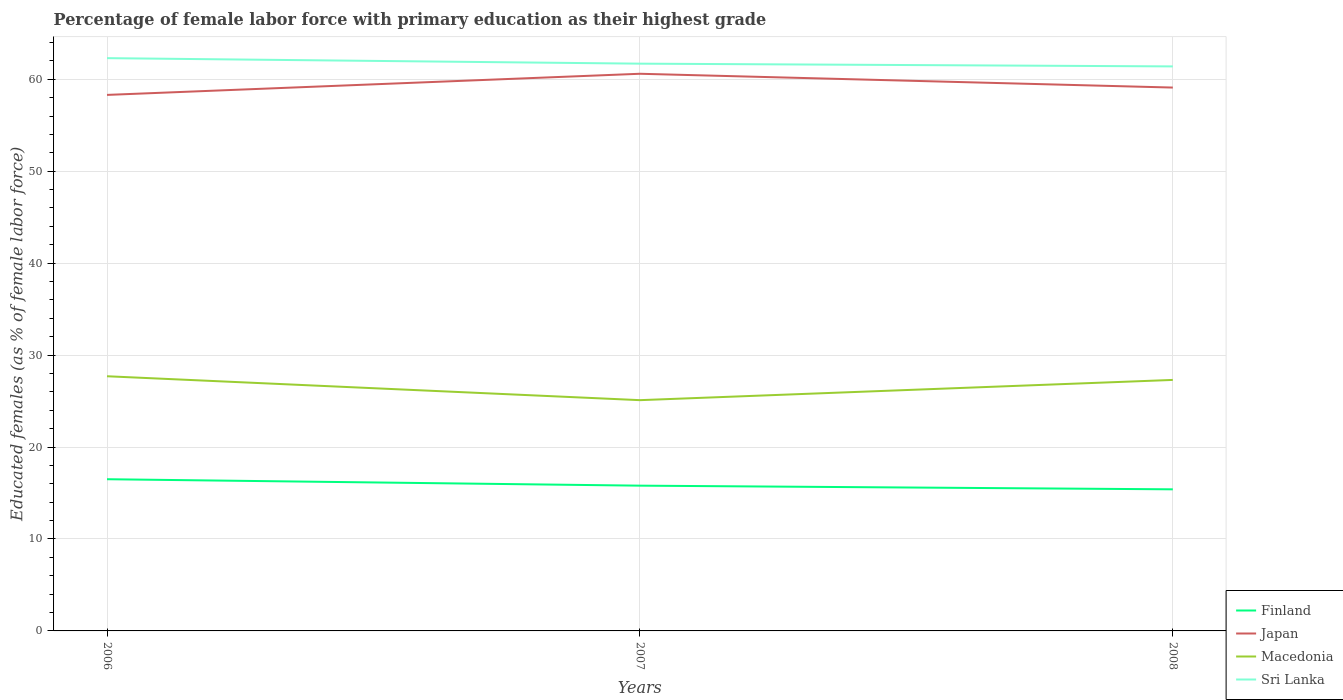Does the line corresponding to Macedonia intersect with the line corresponding to Sri Lanka?
Give a very brief answer. No. Is the number of lines equal to the number of legend labels?
Ensure brevity in your answer.  Yes. Across all years, what is the maximum percentage of female labor force with primary education in Sri Lanka?
Offer a very short reply. 61.4. In which year was the percentage of female labor force with primary education in Macedonia maximum?
Your response must be concise. 2007. What is the total percentage of female labor force with primary education in Finland in the graph?
Offer a very short reply. 1.1. What is the difference between the highest and the second highest percentage of female labor force with primary education in Finland?
Your answer should be very brief. 1.1. What is the difference between the highest and the lowest percentage of female labor force with primary education in Macedonia?
Offer a terse response. 2. How many lines are there?
Offer a terse response. 4. How many years are there in the graph?
Give a very brief answer. 3. Does the graph contain any zero values?
Your answer should be very brief. No. Does the graph contain grids?
Keep it short and to the point. Yes. How many legend labels are there?
Your response must be concise. 4. How are the legend labels stacked?
Ensure brevity in your answer.  Vertical. What is the title of the graph?
Offer a very short reply. Percentage of female labor force with primary education as their highest grade. Does "Peru" appear as one of the legend labels in the graph?
Your response must be concise. No. What is the label or title of the X-axis?
Provide a short and direct response. Years. What is the label or title of the Y-axis?
Offer a very short reply. Educated females (as % of female labor force). What is the Educated females (as % of female labor force) of Japan in 2006?
Your answer should be compact. 58.3. What is the Educated females (as % of female labor force) of Macedonia in 2006?
Offer a very short reply. 27.7. What is the Educated females (as % of female labor force) of Sri Lanka in 2006?
Make the answer very short. 62.3. What is the Educated females (as % of female labor force) of Finland in 2007?
Your answer should be compact. 15.8. What is the Educated females (as % of female labor force) in Japan in 2007?
Provide a short and direct response. 60.6. What is the Educated females (as % of female labor force) in Macedonia in 2007?
Provide a succinct answer. 25.1. What is the Educated females (as % of female labor force) of Sri Lanka in 2007?
Offer a very short reply. 61.7. What is the Educated females (as % of female labor force) of Finland in 2008?
Offer a terse response. 15.4. What is the Educated females (as % of female labor force) of Japan in 2008?
Ensure brevity in your answer.  59.1. What is the Educated females (as % of female labor force) of Macedonia in 2008?
Keep it short and to the point. 27.3. What is the Educated females (as % of female labor force) in Sri Lanka in 2008?
Offer a terse response. 61.4. Across all years, what is the maximum Educated females (as % of female labor force) of Japan?
Ensure brevity in your answer.  60.6. Across all years, what is the maximum Educated females (as % of female labor force) of Macedonia?
Provide a succinct answer. 27.7. Across all years, what is the maximum Educated females (as % of female labor force) of Sri Lanka?
Keep it short and to the point. 62.3. Across all years, what is the minimum Educated females (as % of female labor force) of Finland?
Give a very brief answer. 15.4. Across all years, what is the minimum Educated females (as % of female labor force) in Japan?
Provide a short and direct response. 58.3. Across all years, what is the minimum Educated females (as % of female labor force) in Macedonia?
Your answer should be compact. 25.1. Across all years, what is the minimum Educated females (as % of female labor force) in Sri Lanka?
Make the answer very short. 61.4. What is the total Educated females (as % of female labor force) in Finland in the graph?
Provide a succinct answer. 47.7. What is the total Educated females (as % of female labor force) in Japan in the graph?
Keep it short and to the point. 178. What is the total Educated females (as % of female labor force) in Macedonia in the graph?
Ensure brevity in your answer.  80.1. What is the total Educated females (as % of female labor force) in Sri Lanka in the graph?
Give a very brief answer. 185.4. What is the difference between the Educated females (as % of female labor force) in Macedonia in 2006 and that in 2007?
Offer a very short reply. 2.6. What is the difference between the Educated females (as % of female labor force) of Sri Lanka in 2006 and that in 2007?
Keep it short and to the point. 0.6. What is the difference between the Educated females (as % of female labor force) in Japan in 2006 and that in 2008?
Your answer should be compact. -0.8. What is the difference between the Educated females (as % of female labor force) in Macedonia in 2006 and that in 2008?
Keep it short and to the point. 0.4. What is the difference between the Educated females (as % of female labor force) in Sri Lanka in 2006 and that in 2008?
Keep it short and to the point. 0.9. What is the difference between the Educated females (as % of female labor force) of Macedonia in 2007 and that in 2008?
Your response must be concise. -2.2. What is the difference between the Educated females (as % of female labor force) of Sri Lanka in 2007 and that in 2008?
Make the answer very short. 0.3. What is the difference between the Educated females (as % of female labor force) in Finland in 2006 and the Educated females (as % of female labor force) in Japan in 2007?
Offer a terse response. -44.1. What is the difference between the Educated females (as % of female labor force) of Finland in 2006 and the Educated females (as % of female labor force) of Macedonia in 2007?
Ensure brevity in your answer.  -8.6. What is the difference between the Educated females (as % of female labor force) of Finland in 2006 and the Educated females (as % of female labor force) of Sri Lanka in 2007?
Keep it short and to the point. -45.2. What is the difference between the Educated females (as % of female labor force) of Japan in 2006 and the Educated females (as % of female labor force) of Macedonia in 2007?
Offer a very short reply. 33.2. What is the difference between the Educated females (as % of female labor force) in Japan in 2006 and the Educated females (as % of female labor force) in Sri Lanka in 2007?
Your response must be concise. -3.4. What is the difference between the Educated females (as % of female labor force) in Macedonia in 2006 and the Educated females (as % of female labor force) in Sri Lanka in 2007?
Offer a very short reply. -34. What is the difference between the Educated females (as % of female labor force) of Finland in 2006 and the Educated females (as % of female labor force) of Japan in 2008?
Offer a terse response. -42.6. What is the difference between the Educated females (as % of female labor force) in Finland in 2006 and the Educated females (as % of female labor force) in Macedonia in 2008?
Give a very brief answer. -10.8. What is the difference between the Educated females (as % of female labor force) of Finland in 2006 and the Educated females (as % of female labor force) of Sri Lanka in 2008?
Offer a very short reply. -44.9. What is the difference between the Educated females (as % of female labor force) in Japan in 2006 and the Educated females (as % of female labor force) in Macedonia in 2008?
Ensure brevity in your answer.  31. What is the difference between the Educated females (as % of female labor force) in Macedonia in 2006 and the Educated females (as % of female labor force) in Sri Lanka in 2008?
Give a very brief answer. -33.7. What is the difference between the Educated females (as % of female labor force) in Finland in 2007 and the Educated females (as % of female labor force) in Japan in 2008?
Offer a terse response. -43.3. What is the difference between the Educated females (as % of female labor force) in Finland in 2007 and the Educated females (as % of female labor force) in Sri Lanka in 2008?
Offer a terse response. -45.6. What is the difference between the Educated females (as % of female labor force) of Japan in 2007 and the Educated females (as % of female labor force) of Macedonia in 2008?
Offer a terse response. 33.3. What is the difference between the Educated females (as % of female labor force) in Japan in 2007 and the Educated females (as % of female labor force) in Sri Lanka in 2008?
Make the answer very short. -0.8. What is the difference between the Educated females (as % of female labor force) in Macedonia in 2007 and the Educated females (as % of female labor force) in Sri Lanka in 2008?
Your answer should be very brief. -36.3. What is the average Educated females (as % of female labor force) of Finland per year?
Provide a short and direct response. 15.9. What is the average Educated females (as % of female labor force) in Japan per year?
Keep it short and to the point. 59.33. What is the average Educated females (as % of female labor force) of Macedonia per year?
Offer a very short reply. 26.7. What is the average Educated females (as % of female labor force) in Sri Lanka per year?
Your answer should be compact. 61.8. In the year 2006, what is the difference between the Educated females (as % of female labor force) in Finland and Educated females (as % of female labor force) in Japan?
Give a very brief answer. -41.8. In the year 2006, what is the difference between the Educated females (as % of female labor force) of Finland and Educated females (as % of female labor force) of Sri Lanka?
Provide a short and direct response. -45.8. In the year 2006, what is the difference between the Educated females (as % of female labor force) of Japan and Educated females (as % of female labor force) of Macedonia?
Make the answer very short. 30.6. In the year 2006, what is the difference between the Educated females (as % of female labor force) of Japan and Educated females (as % of female labor force) of Sri Lanka?
Offer a very short reply. -4. In the year 2006, what is the difference between the Educated females (as % of female labor force) of Macedonia and Educated females (as % of female labor force) of Sri Lanka?
Offer a terse response. -34.6. In the year 2007, what is the difference between the Educated females (as % of female labor force) in Finland and Educated females (as % of female labor force) in Japan?
Ensure brevity in your answer.  -44.8. In the year 2007, what is the difference between the Educated females (as % of female labor force) in Finland and Educated females (as % of female labor force) in Sri Lanka?
Give a very brief answer. -45.9. In the year 2007, what is the difference between the Educated females (as % of female labor force) in Japan and Educated females (as % of female labor force) in Macedonia?
Your answer should be compact. 35.5. In the year 2007, what is the difference between the Educated females (as % of female labor force) in Japan and Educated females (as % of female labor force) in Sri Lanka?
Offer a terse response. -1.1. In the year 2007, what is the difference between the Educated females (as % of female labor force) in Macedonia and Educated females (as % of female labor force) in Sri Lanka?
Offer a terse response. -36.6. In the year 2008, what is the difference between the Educated females (as % of female labor force) in Finland and Educated females (as % of female labor force) in Japan?
Give a very brief answer. -43.7. In the year 2008, what is the difference between the Educated females (as % of female labor force) in Finland and Educated females (as % of female labor force) in Macedonia?
Your answer should be compact. -11.9. In the year 2008, what is the difference between the Educated females (as % of female labor force) of Finland and Educated females (as % of female labor force) of Sri Lanka?
Make the answer very short. -46. In the year 2008, what is the difference between the Educated females (as % of female labor force) in Japan and Educated females (as % of female labor force) in Macedonia?
Your answer should be compact. 31.8. In the year 2008, what is the difference between the Educated females (as % of female labor force) of Japan and Educated females (as % of female labor force) of Sri Lanka?
Your answer should be compact. -2.3. In the year 2008, what is the difference between the Educated females (as % of female labor force) of Macedonia and Educated females (as % of female labor force) of Sri Lanka?
Offer a very short reply. -34.1. What is the ratio of the Educated females (as % of female labor force) in Finland in 2006 to that in 2007?
Offer a very short reply. 1.04. What is the ratio of the Educated females (as % of female labor force) of Macedonia in 2006 to that in 2007?
Your answer should be compact. 1.1. What is the ratio of the Educated females (as % of female labor force) in Sri Lanka in 2006 to that in 2007?
Offer a very short reply. 1.01. What is the ratio of the Educated females (as % of female labor force) in Finland in 2006 to that in 2008?
Provide a short and direct response. 1.07. What is the ratio of the Educated females (as % of female labor force) of Japan in 2006 to that in 2008?
Your response must be concise. 0.99. What is the ratio of the Educated females (as % of female labor force) in Macedonia in 2006 to that in 2008?
Give a very brief answer. 1.01. What is the ratio of the Educated females (as % of female labor force) in Sri Lanka in 2006 to that in 2008?
Ensure brevity in your answer.  1.01. What is the ratio of the Educated females (as % of female labor force) in Japan in 2007 to that in 2008?
Make the answer very short. 1.03. What is the ratio of the Educated females (as % of female labor force) in Macedonia in 2007 to that in 2008?
Keep it short and to the point. 0.92. What is the ratio of the Educated females (as % of female labor force) in Sri Lanka in 2007 to that in 2008?
Ensure brevity in your answer.  1. What is the difference between the highest and the second highest Educated females (as % of female labor force) of Finland?
Your answer should be compact. 0.7. What is the difference between the highest and the second highest Educated females (as % of female labor force) in Macedonia?
Your response must be concise. 0.4. What is the difference between the highest and the lowest Educated females (as % of female labor force) of Macedonia?
Provide a succinct answer. 2.6. 